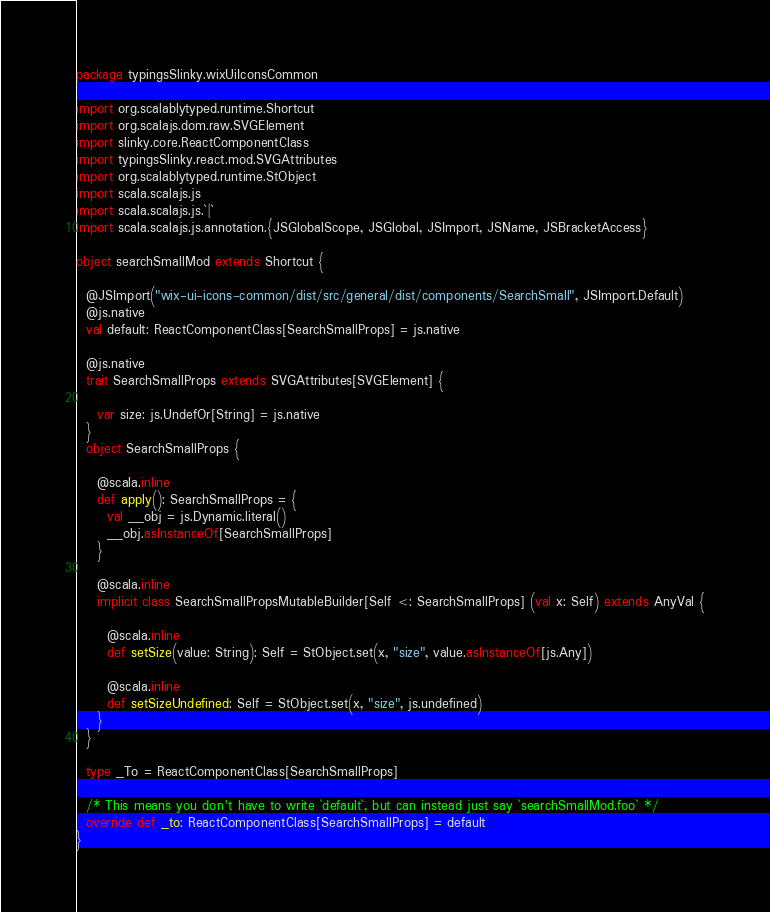<code> <loc_0><loc_0><loc_500><loc_500><_Scala_>package typingsSlinky.wixUiIconsCommon

import org.scalablytyped.runtime.Shortcut
import org.scalajs.dom.raw.SVGElement
import slinky.core.ReactComponentClass
import typingsSlinky.react.mod.SVGAttributes
import org.scalablytyped.runtime.StObject
import scala.scalajs.js
import scala.scalajs.js.`|`
import scala.scalajs.js.annotation.{JSGlobalScope, JSGlobal, JSImport, JSName, JSBracketAccess}

object searchSmallMod extends Shortcut {
  
  @JSImport("wix-ui-icons-common/dist/src/general/dist/components/SearchSmall", JSImport.Default)
  @js.native
  val default: ReactComponentClass[SearchSmallProps] = js.native
  
  @js.native
  trait SearchSmallProps extends SVGAttributes[SVGElement] {
    
    var size: js.UndefOr[String] = js.native
  }
  object SearchSmallProps {
    
    @scala.inline
    def apply(): SearchSmallProps = {
      val __obj = js.Dynamic.literal()
      __obj.asInstanceOf[SearchSmallProps]
    }
    
    @scala.inline
    implicit class SearchSmallPropsMutableBuilder[Self <: SearchSmallProps] (val x: Self) extends AnyVal {
      
      @scala.inline
      def setSize(value: String): Self = StObject.set(x, "size", value.asInstanceOf[js.Any])
      
      @scala.inline
      def setSizeUndefined: Self = StObject.set(x, "size", js.undefined)
    }
  }
  
  type _To = ReactComponentClass[SearchSmallProps]
  
  /* This means you don't have to write `default`, but can instead just say `searchSmallMod.foo` */
  override def _to: ReactComponentClass[SearchSmallProps] = default
}
</code> 